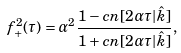Convert formula to latex. <formula><loc_0><loc_0><loc_500><loc_500>f _ { + } ^ { 2 } ( \tau ) = \alpha ^ { 2 } \frac { 1 - c n [ 2 \alpha \tau | \hat { k } ] } { 1 + c n [ 2 \alpha \tau | \hat { k } ] } ,</formula> 